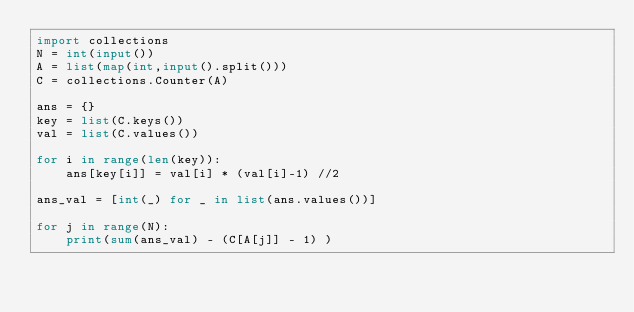<code> <loc_0><loc_0><loc_500><loc_500><_Python_>import collections
N = int(input())
A = list(map(int,input().split()))
C = collections.Counter(A)

ans = {}
key = list(C.keys())
val = list(C.values())

for i in range(len(key)):
    ans[key[i]] = val[i] * (val[i]-1) //2

ans_val = [int(_) for _ in list(ans.values())]

for j in range(N):
    print(sum(ans_val) - (C[A[j]] - 1) )</code> 